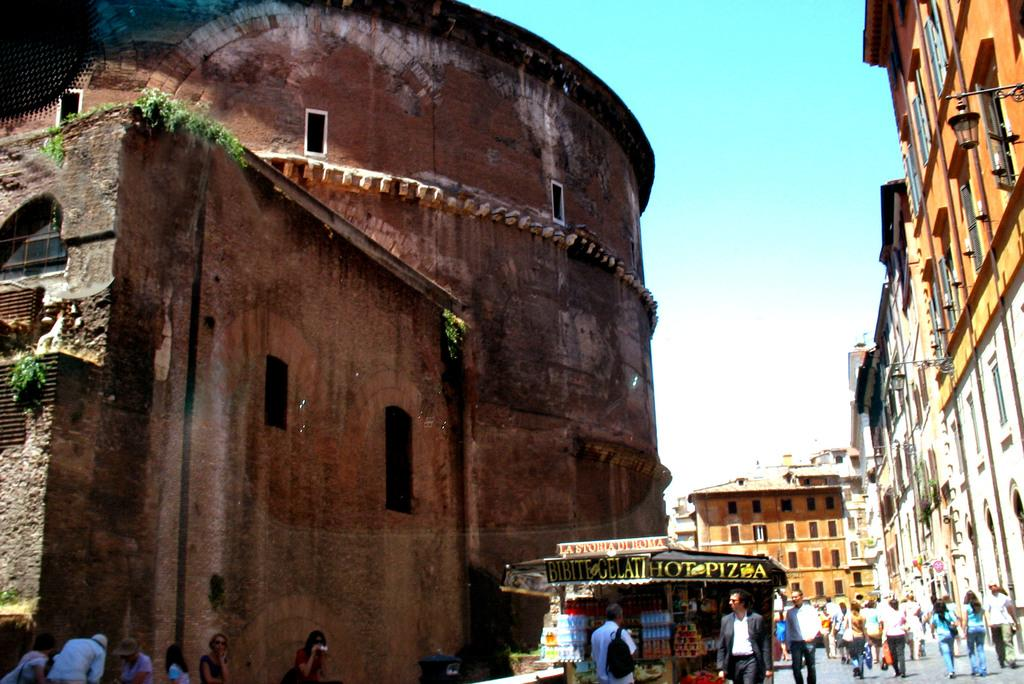What is the main structure visible in the image? There is a monument in the image. What is located in front of the monument? There is a shop in front of the monument. What is happening on the road in the image? People are moving on the road in the image. What can be seen on the right side of the image? There are buildings on the right side of the image. What type of wood is used to construct the monument in the image? There is no information about the construction material of the monument in the image. 